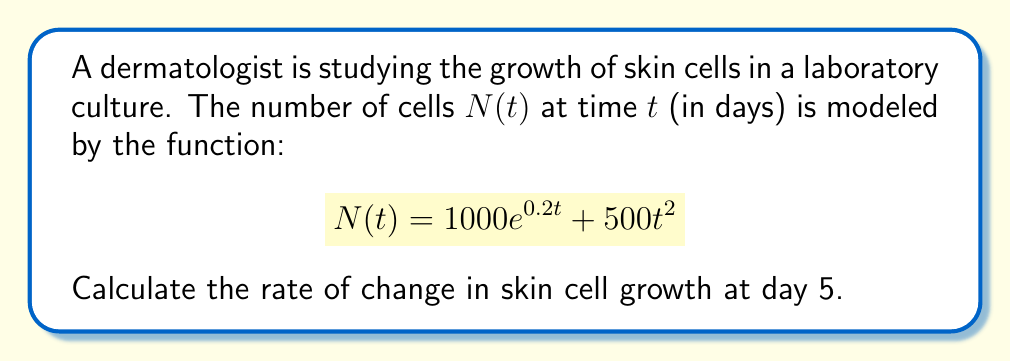Teach me how to tackle this problem. To find the rate of change in skin cell growth at day 5, we need to calculate the derivative of the function $N(t)$ and evaluate it at $t=5$. Let's break this down step-by-step:

1. The given function is $N(t) = 1000e^{0.2t} + 500t^2$

2. To find the rate of change, we need to differentiate $N(t)$ with respect to $t$:

   $$\frac{dN}{dt} = \frac{d}{dt}(1000e^{0.2t}) + \frac{d}{dt}(500t^2)$$

3. Using the rules of differentiation:
   - For $1000e^{0.2t}$, we use the chain rule: $\frac{d}{dt}(e^{ax}) = ae^{ax}$
   - For $500t^2$, we use the power rule: $\frac{d}{dt}(x^n) = nx^{n-1}$

   $$\frac{dN}{dt} = 1000 \cdot 0.2e^{0.2t} + 500 \cdot 2t$$
   $$\frac{dN}{dt} = 200e^{0.2t} + 1000t$$

4. Now we evaluate this derivative at $t=5$:

   $$\left.\frac{dN}{dt}\right|_{t=5} = 200e^{0.2(5)} + 1000(5)$$
   $$= 200e^1 + 5000$$
   $$\approx 200 \cdot 2.71828 + 5000$$
   $$\approx 543.66 + 5000$$
   $$\approx 5543.66$$

This result represents the instantaneous rate of change in the number of skin cells per day at day 5.
Answer: The rate of change in skin cell growth at day 5 is approximately 5543.66 cells per day. 